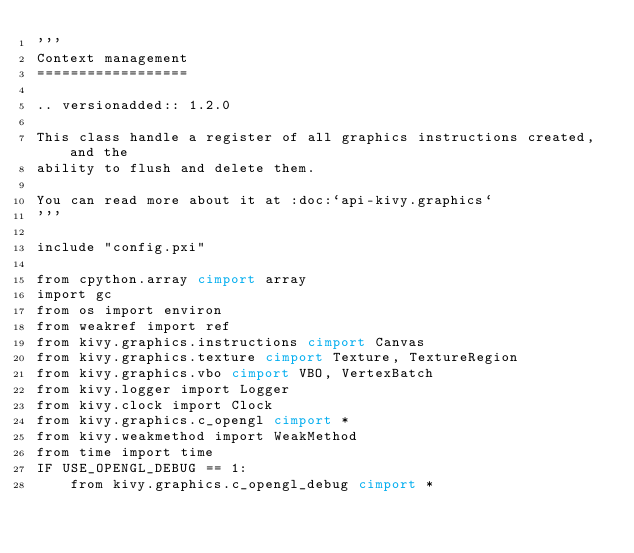<code> <loc_0><loc_0><loc_500><loc_500><_Cython_>'''
Context management
==================

.. versionadded:: 1.2.0

This class handle a register of all graphics instructions created, and the
ability to flush and delete them.

You can read more about it at :doc:`api-kivy.graphics`
'''

include "config.pxi"

from cpython.array cimport array
import gc
from os import environ
from weakref import ref
from kivy.graphics.instructions cimport Canvas
from kivy.graphics.texture cimport Texture, TextureRegion
from kivy.graphics.vbo cimport VBO, VertexBatch
from kivy.logger import Logger
from kivy.clock import Clock
from kivy.graphics.c_opengl cimport *
from kivy.weakmethod import WeakMethod
from time import time
IF USE_OPENGL_DEBUG == 1:
    from kivy.graphics.c_opengl_debug cimport *</code> 